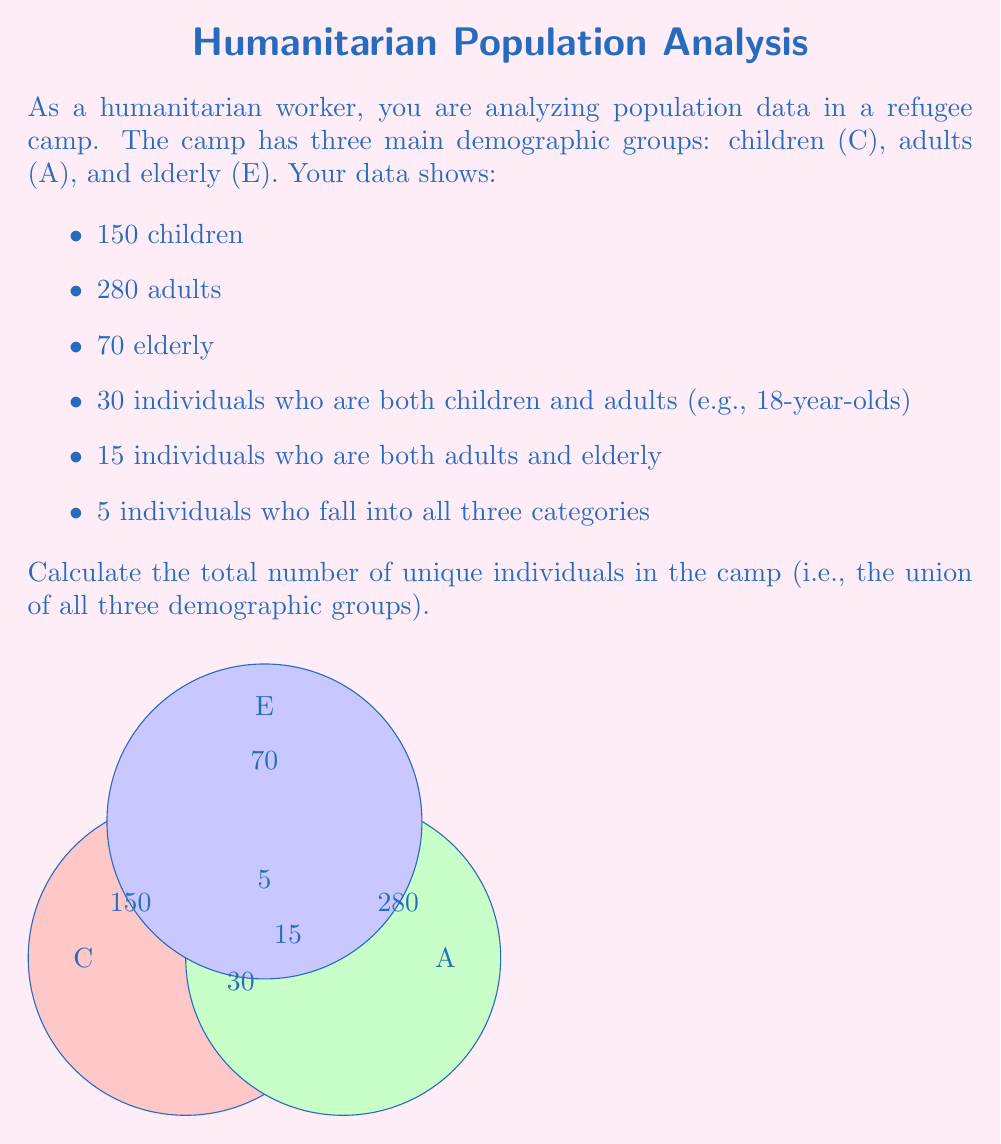Show me your answer to this math problem. To solve this problem, we'll use the principle of inclusion-exclusion for three sets. Let's break it down step-by-step:

1) First, let's define our sets:
   $C$: Children
   $A$: Adults
   $E$: Elderly

2) The principle of inclusion-exclusion for three sets is:
   $$|C \cup A \cup E| = |C| + |A| + |E| - |C \cap A| - |A \cap E| - |C \cap E| + |C \cap A \cap E|$$

3) We know:
   $|C| = 150$
   $|A| = 280$
   $|E| = 70$
   $|C \cap A| = 30$
   $|A \cap E| = 15$
   $|C \cap E| = 0$ (not given, but logically it's 0)
   $|C \cap A \cap E| = 5$

4) Let's substitute these values into our equation:
   $$|C \cup A \cup E| = 150 + 280 + 70 - 30 - 15 - 0 + 5$$

5) Now we can calculate:
   $$|C \cup A \cup E| = 500 - 45 + 5 = 460$$

Therefore, the total number of unique individuals in the camp is 460.
Answer: 460 